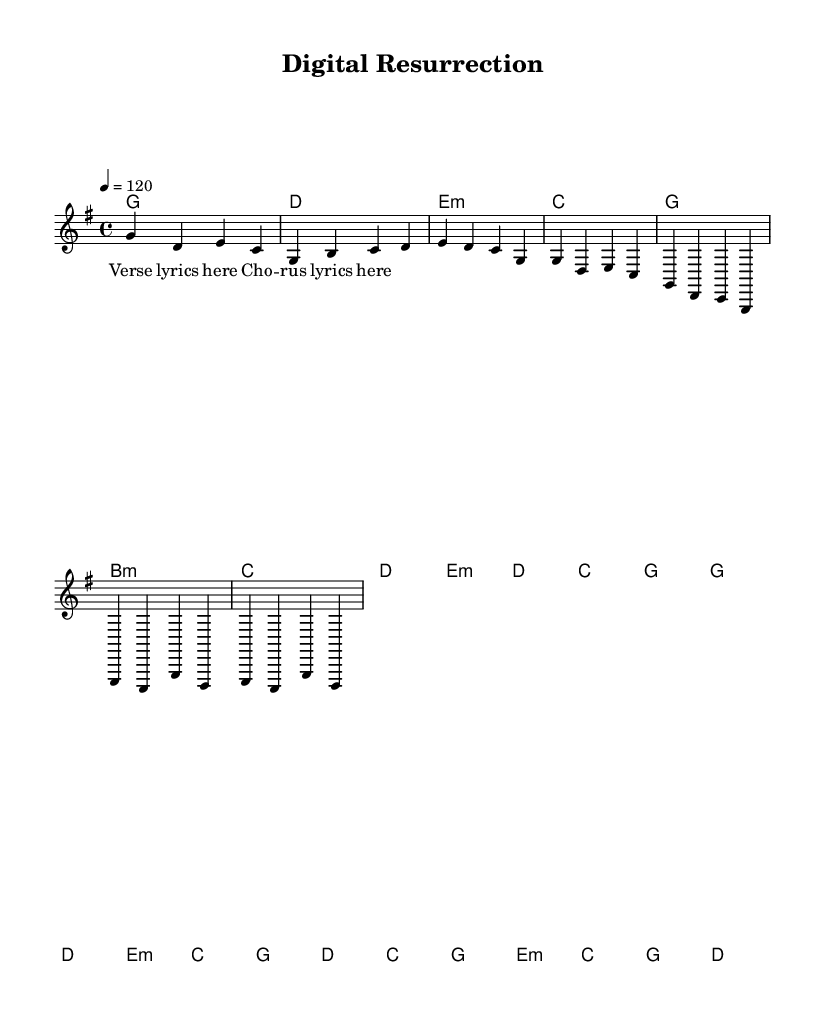What is the key signature of this music? The key signature is G major, which has one sharp (F#).
Answer: G major What is the time signature of this music? The time signature is indicated as 4/4 at the beginning of the piece, meaning there are four beats per measure.
Answer: 4/4 What is the tempo marking for this music? The tempo marking indicates a speed of 120 beats per minute, defined as '4 = 120'.
Answer: 120 Which chord is played in the Intro section? The Intro section starts with the G major chord, as shown in the chord line.
Answer: G How many measures are in the Chorus section? The Chorus section consists of four measures, as can be counted directly from the music notation.
Answer: 4 What is the last chord in the Bridge section? The last chord in the Bridge section is D major, indicated by the corresponding chord symbol at the end of that section.
Answer: D How does the theme of technological innovation relate to the lyrics in the Chorus? The lyrics of the Chorus embody themes of renewal and resurrection, paralleling concepts in technology such as digital revival and advancement.
Answer: Digital resurrection 